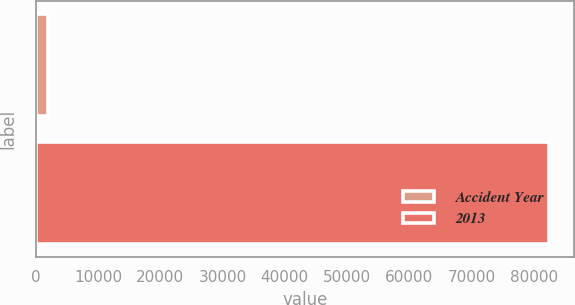Convert chart. <chart><loc_0><loc_0><loc_500><loc_500><bar_chart><fcel>Accident Year<fcel>2013<nl><fcel>2014<fcel>82408<nl></chart> 